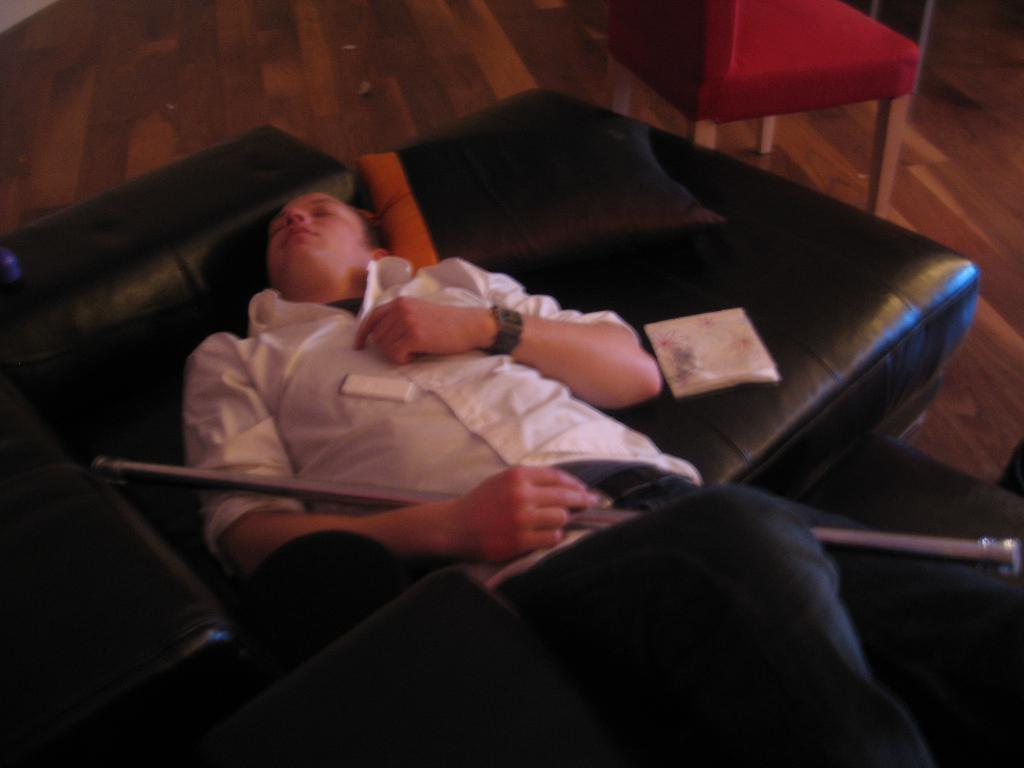What is the main subject of the picture? The main subject of the picture is a man. What is the man doing in the picture? The man is lying on a sofa bed. What is the man wearing in the picture? The man is wearing a white t-shirt. What object is the man holding in the picture? The man is holding a rod. What type of song is the man singing in the image? There is no indication in the image that the man is singing a song, so it cannot be determined from the picture. 